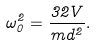Convert formula to latex. <formula><loc_0><loc_0><loc_500><loc_500>\omega _ { 0 } ^ { 2 } = \frac { 3 2 V } { m d ^ { 2 } } .</formula> 